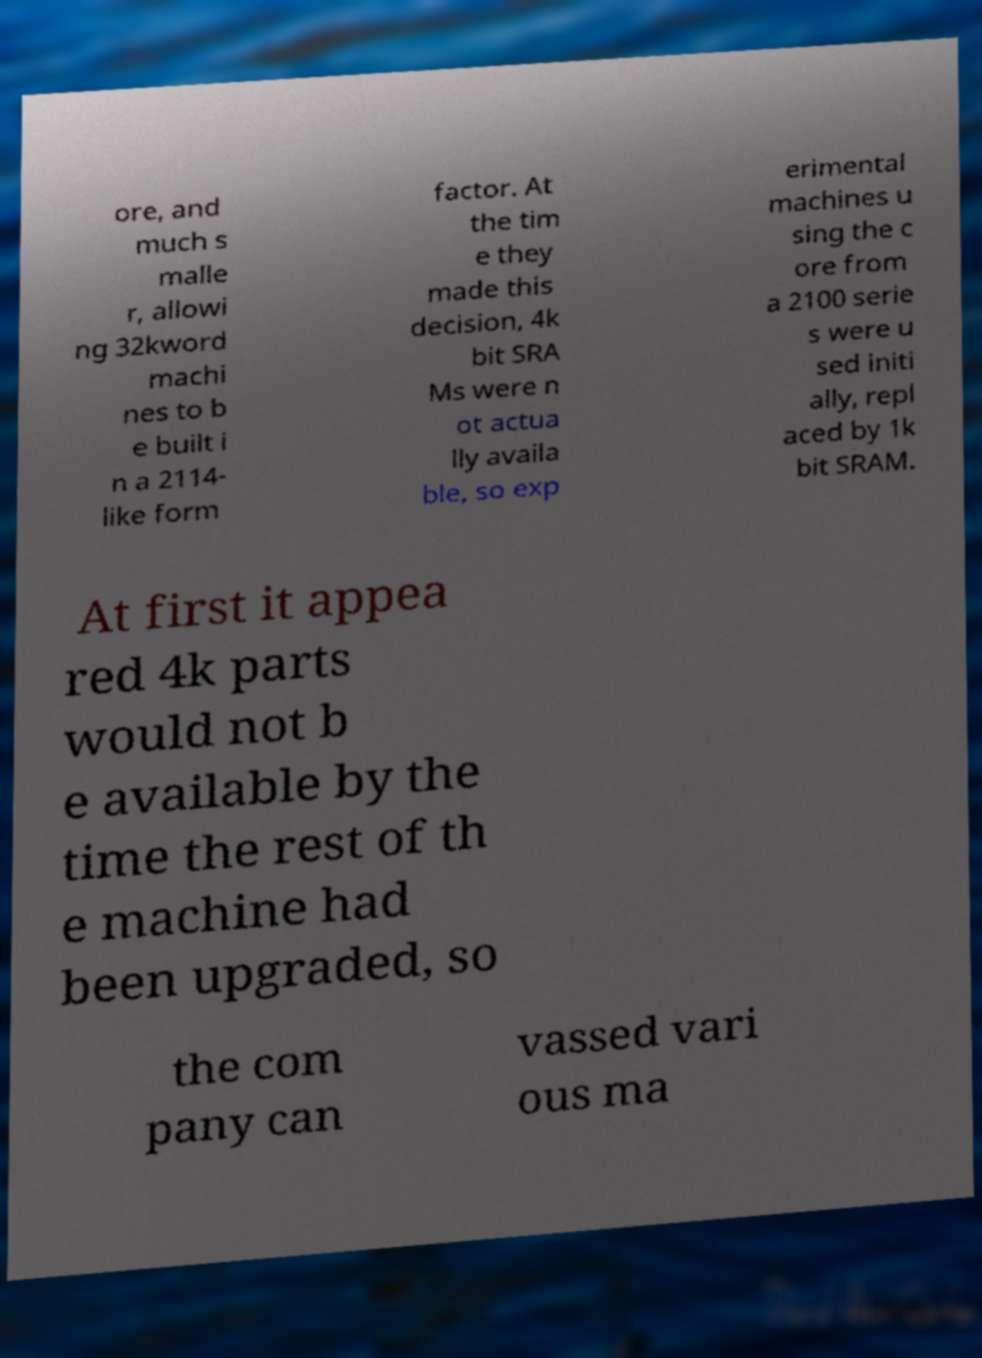Could you extract and type out the text from this image? ore, and much s malle r, allowi ng 32kword machi nes to b e built i n a 2114- like form factor. At the tim e they made this decision, 4k bit SRA Ms were n ot actua lly availa ble, so exp erimental machines u sing the c ore from a 2100 serie s were u sed initi ally, repl aced by 1k bit SRAM. At first it appea red 4k parts would not b e available by the time the rest of th e machine had been upgraded, so the com pany can vassed vari ous ma 